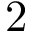<formula> <loc_0><loc_0><loc_500><loc_500>2</formula> 